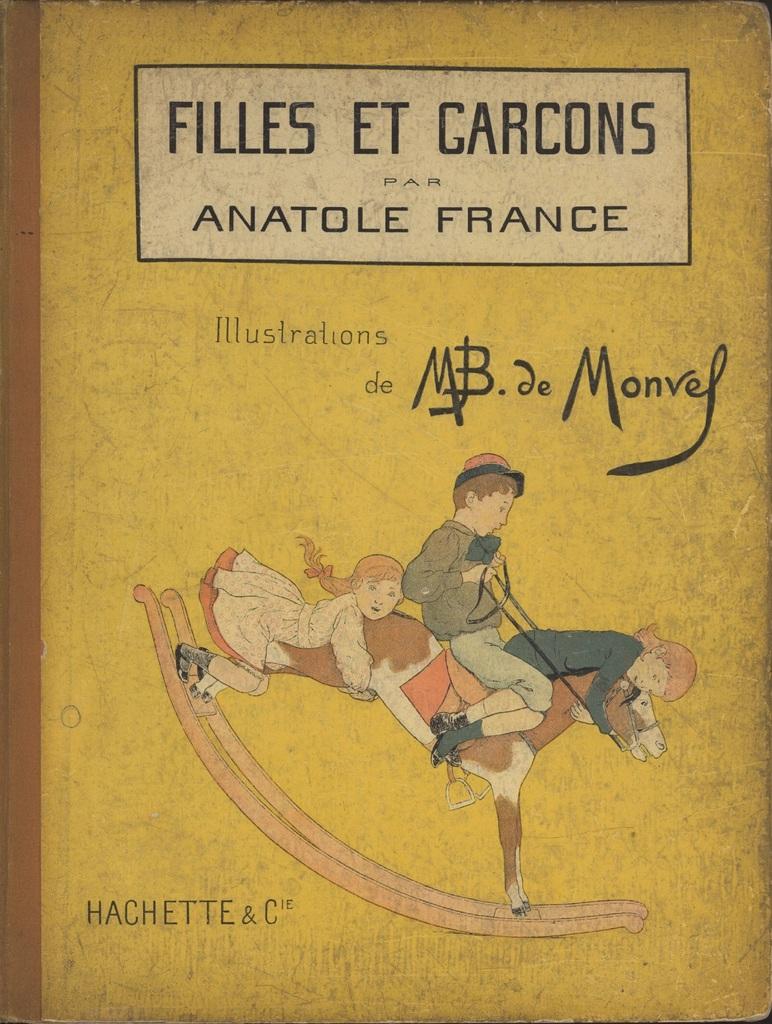What country name is on the book?
Give a very brief answer. France. This is english book?
Your answer should be very brief. No. 